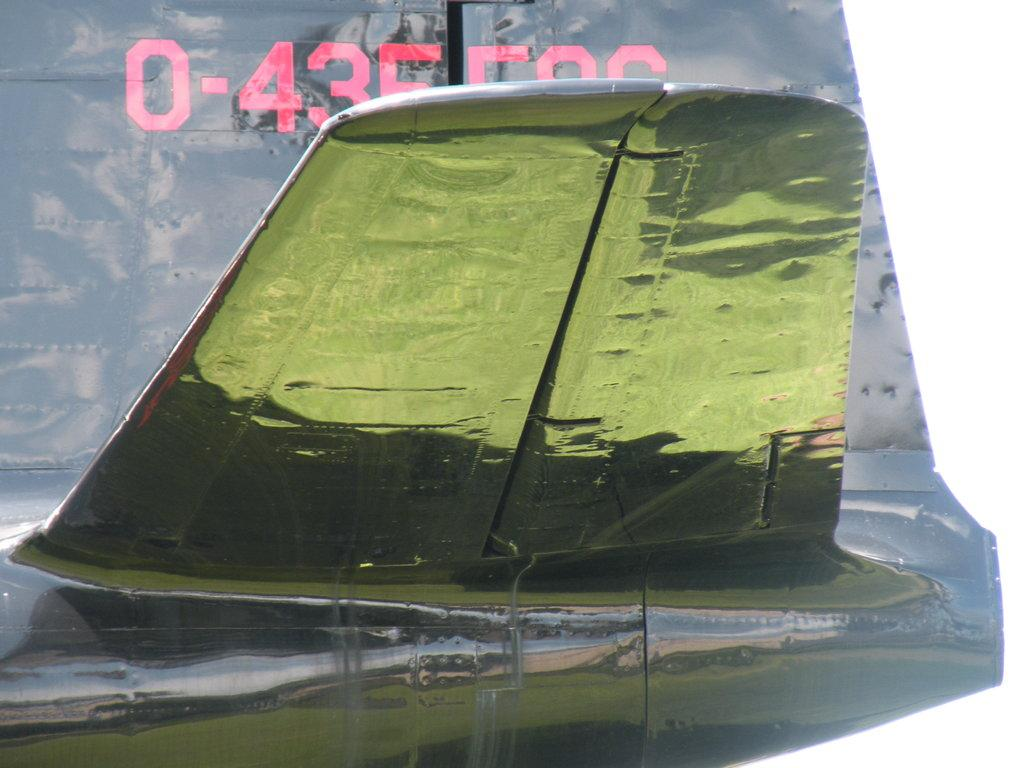What is the color of the main object in the image? The main object in the image has a green color. Can you describe what is written in the background of the image? Unfortunately, the facts provided do not give enough information to determine what is written in the background. Can you tell me how many tigers are visible in the image? There are no tigers present in the image. What is the final score of the game in the image? There is no game or score visible in the image. 